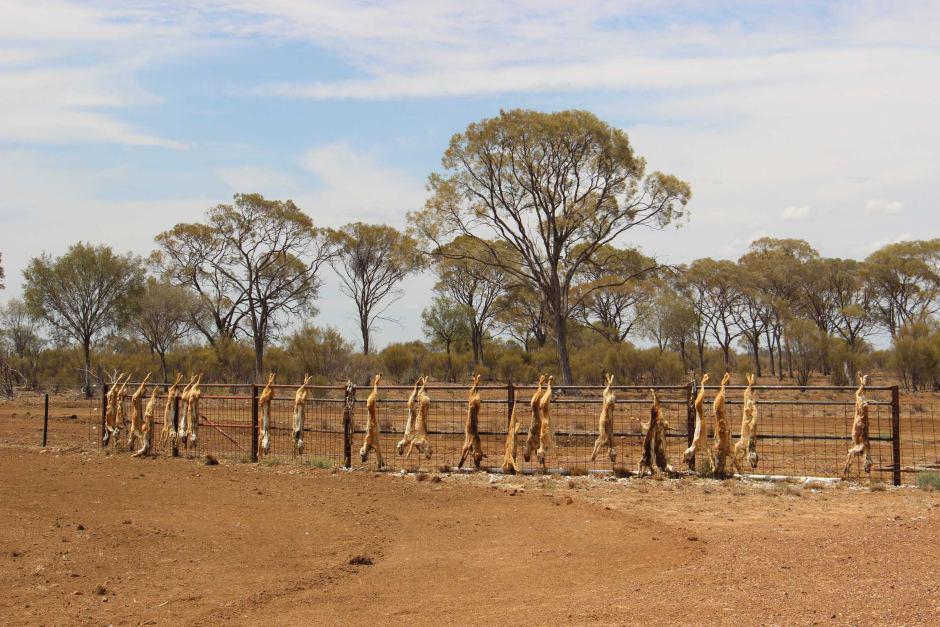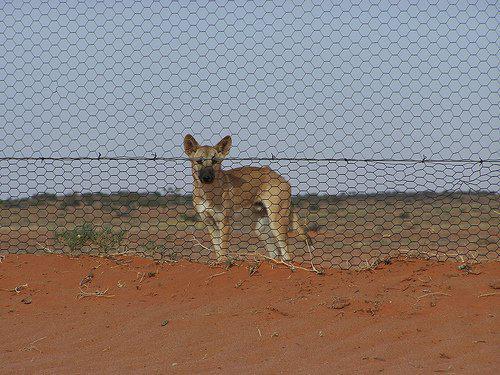The first image is the image on the left, the second image is the image on the right. Evaluate the accuracy of this statement regarding the images: "There is one living animal in the image on the right.". Is it true? Answer yes or no. Yes. The first image is the image on the left, the second image is the image on the right. Analyze the images presented: Is the assertion "An image shows one dingo standing on the ground." valid? Answer yes or no. Yes. 